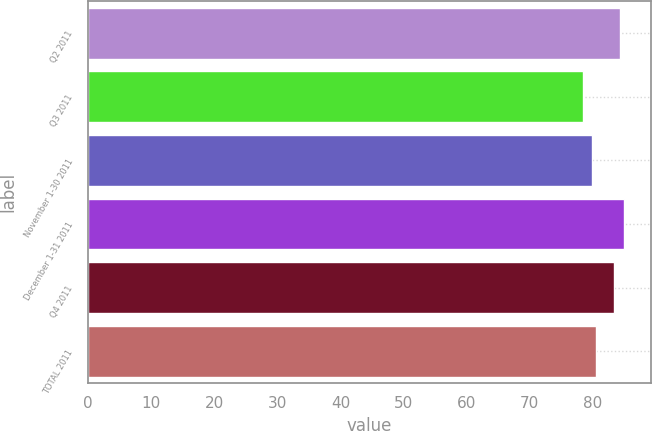Convert chart to OTSL. <chart><loc_0><loc_0><loc_500><loc_500><bar_chart><fcel>Q2 2011<fcel>Q3 2011<fcel>November 1-30 2011<fcel>December 1-31 2011<fcel>Q4 2011<fcel>TOTAL 2011<nl><fcel>84.33<fcel>78.42<fcel>79.86<fcel>84.93<fcel>83.41<fcel>80.46<nl></chart> 